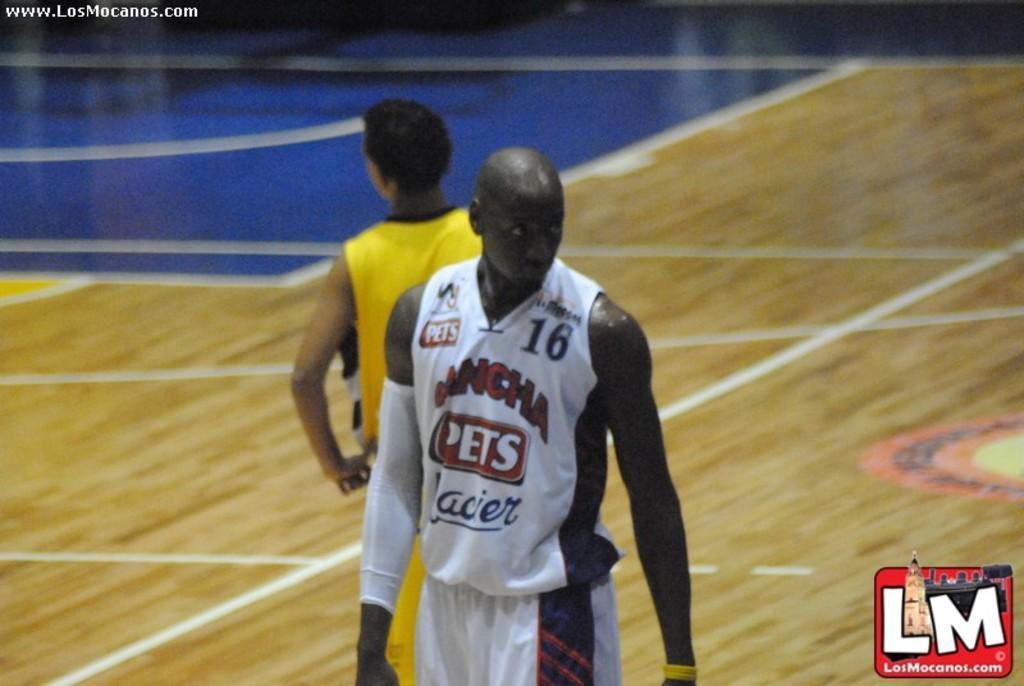Can you describe this image briefly? In this image, I can see two persons standing. In the top left corner and in the bottom right corner of the image, I can see the watermarks. 